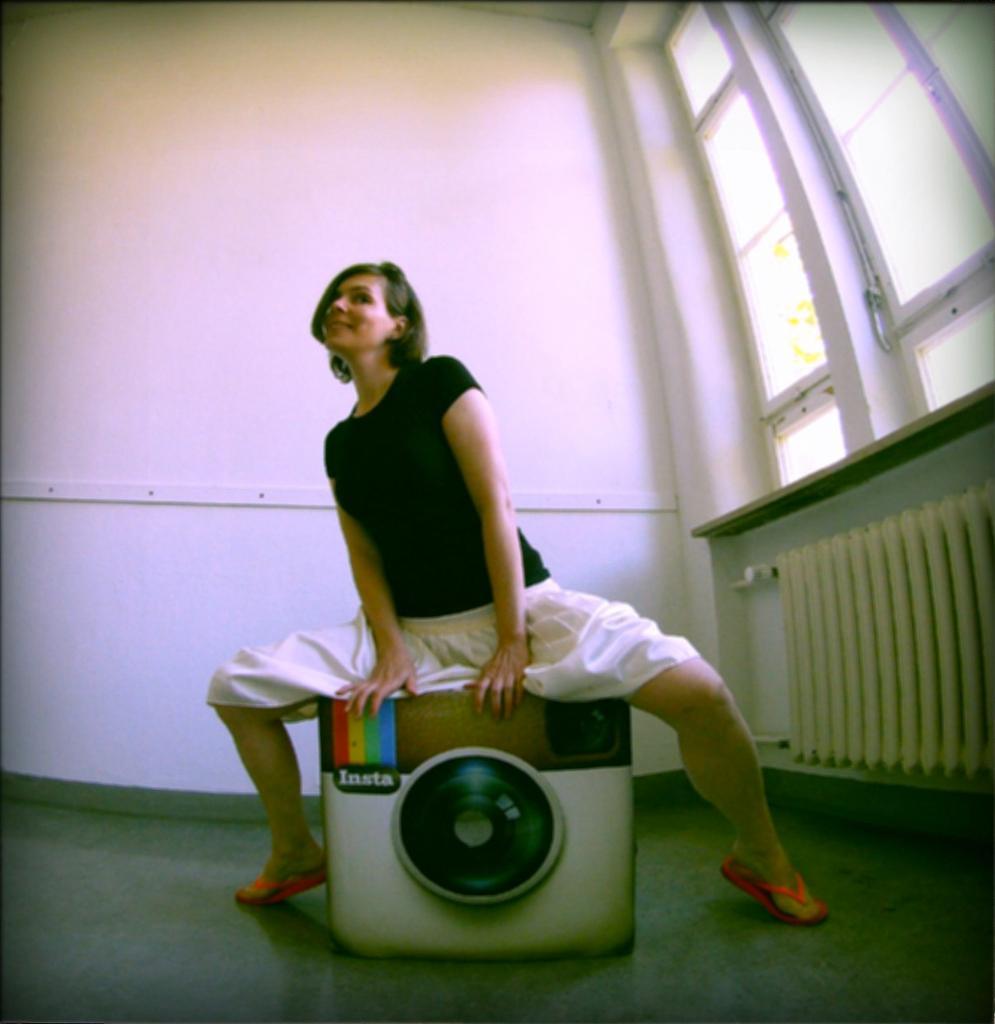Describe this image in one or two sentences. In this image there is a woman sitting on a stool, which is in the model of Instagram icon, and in the background there is a window and a wall. 